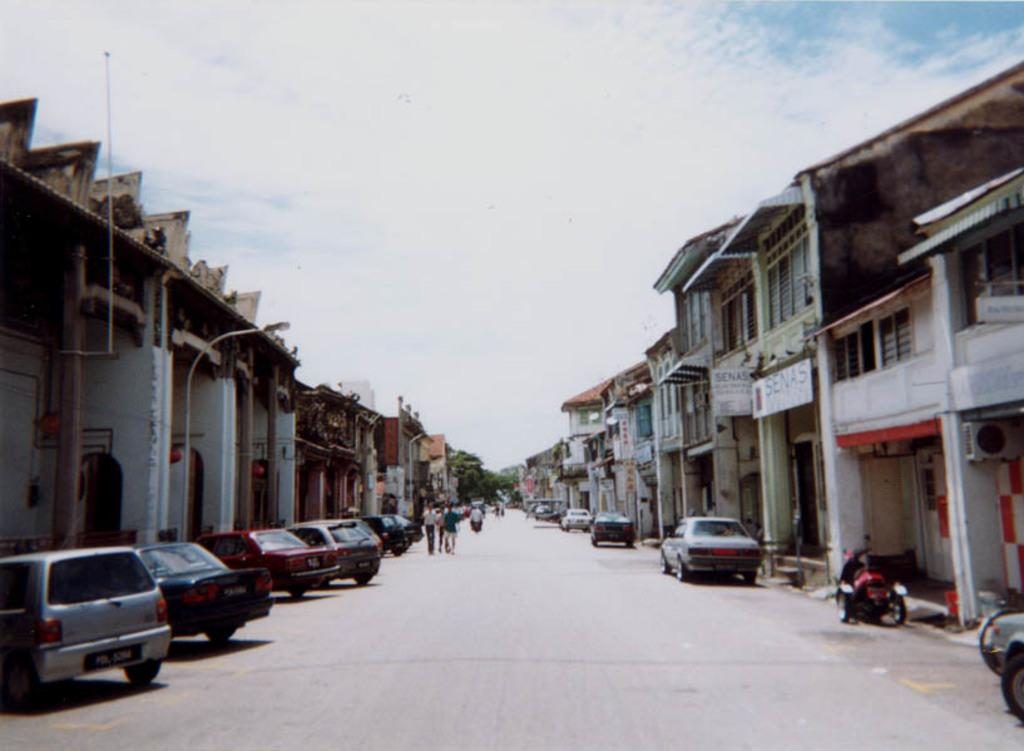Who or what can be seen in the image? There are people in the image. What else is present in the image besides people? There are vehicles on the road, boards, buildings, poles, and lights in the image. Can you describe the background of the image? The sky with clouds is visible in the background of the image. Where is the scarecrow located in the image? There is no scarecrow present in the image. What type of payment is being made in the image? There is no payment being made in the image. 